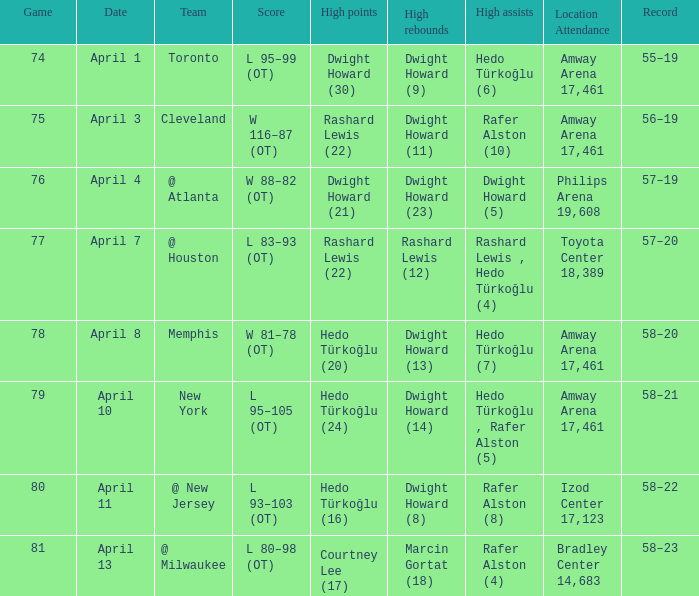Could you parse the entire table? {'header': ['Game', 'Date', 'Team', 'Score', 'High points', 'High rebounds', 'High assists', 'Location Attendance', 'Record'], 'rows': [['74', 'April 1', 'Toronto', 'L 95–99 (OT)', 'Dwight Howard (30)', 'Dwight Howard (9)', 'Hedo Türkoğlu (6)', 'Amway Arena 17,461', '55–19'], ['75', 'April 3', 'Cleveland', 'W 116–87 (OT)', 'Rashard Lewis (22)', 'Dwight Howard (11)', 'Rafer Alston (10)', 'Amway Arena 17,461', '56–19'], ['76', 'April 4', '@ Atlanta', 'W 88–82 (OT)', 'Dwight Howard (21)', 'Dwight Howard (23)', 'Dwight Howard (5)', 'Philips Arena 19,608', '57–19'], ['77', 'April 7', '@ Houston', 'L 83–93 (OT)', 'Rashard Lewis (22)', 'Rashard Lewis (12)', 'Rashard Lewis , Hedo Türkoğlu (4)', 'Toyota Center 18,389', '57–20'], ['78', 'April 8', 'Memphis', 'W 81–78 (OT)', 'Hedo Türkoğlu (20)', 'Dwight Howard (13)', 'Hedo Türkoğlu (7)', 'Amway Arena 17,461', '58–20'], ['79', 'April 10', 'New York', 'L 95–105 (OT)', 'Hedo Türkoğlu (24)', 'Dwight Howard (14)', 'Hedo Türkoğlu , Rafer Alston (5)', 'Amway Arena 17,461', '58–21'], ['80', 'April 11', '@ New Jersey', 'L 93–103 (OT)', 'Hedo Türkoğlu (16)', 'Dwight Howard (8)', 'Rafer Alston (8)', 'Izod Center 17,123', '58–22'], ['81', 'April 13', '@ Milwaukee', 'L 80–98 (OT)', 'Courtney Lee (17)', 'Marcin Gortat (18)', 'Rafer Alston (4)', 'Bradley Center 14,683', '58–23']]} Which player had the highest points in game 79? Hedo Türkoğlu (24). 